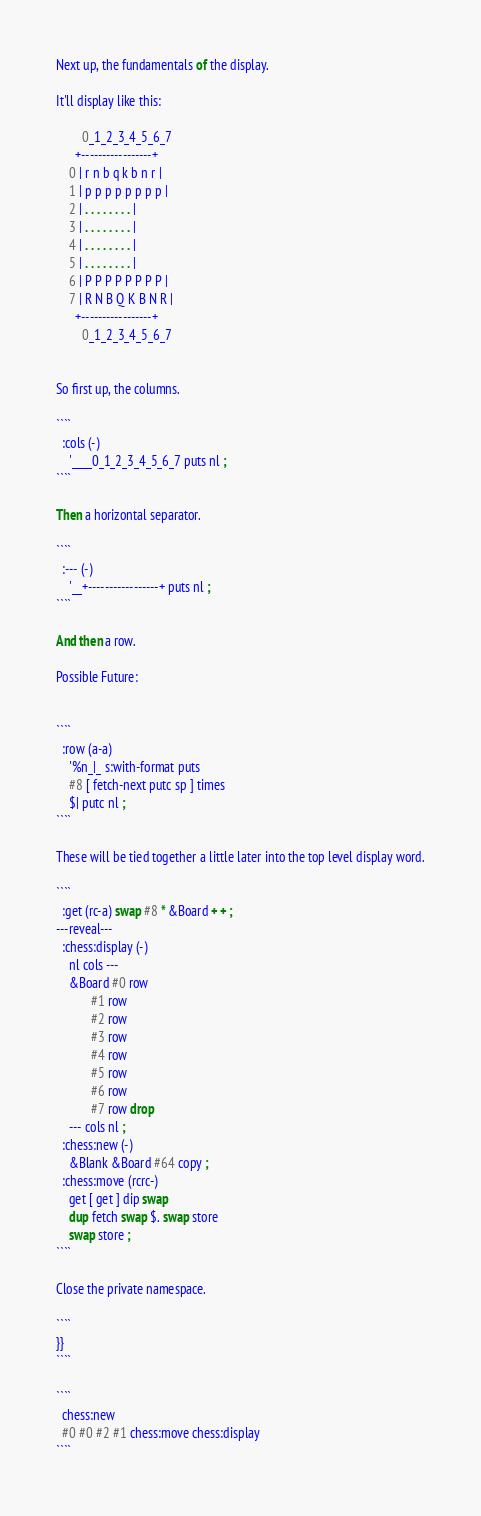<code> <loc_0><loc_0><loc_500><loc_500><_Forth_>Next up, the fundamentals of the display.

It'll display like this:

        0_1_2_3_4_5_6_7
      +-----------------+
    0 | r n b q k b n r |
    1 | p p p p p p p p |
    2 | . . . . . . . . |
    3 | . . . . . . . . |
    4 | . . . . . . . . |
    5 | . . . . . . . . |
    6 | P P P P P P P P |
    7 | R N B Q K B N R |
      +-----------------+
        0_1_2_3_4_5_6_7


So first up, the columns.

````
  :cols (-)
    '____0_1_2_3_4_5_6_7 puts nl ;
````

Then a horizontal separator.

````
  :--- (-) 
    '__+-----------------+ puts nl ;
````

And then a row.

Possible Future:


````
  :row (a-a)
    '%n_|_ s:with-format puts
    #8 [ fetch-next putc sp ] times
    $| putc nl ;
````

These will be tied together a little later into the top level display word.

````
  :get (rc-a) swap #8 * &Board + + ;
---reveal---
  :chess:display (-)
    nl cols ---
    &Board #0 row
           #1 row
           #2 row
           #3 row
           #4 row
           #5 row
           #6 row
           #7 row drop
    --- cols nl ;
  :chess:new (-)
    &Blank &Board #64 copy ;
  :chess:move (rcrc-)
    get [ get ] dip swap
    dup fetch swap $. swap store
    swap store ;
````

Close the private namespace.

````
}}
````

````
  chess:new
  #0 #0 #2 #1 chess:move chess:display
````
</code> 